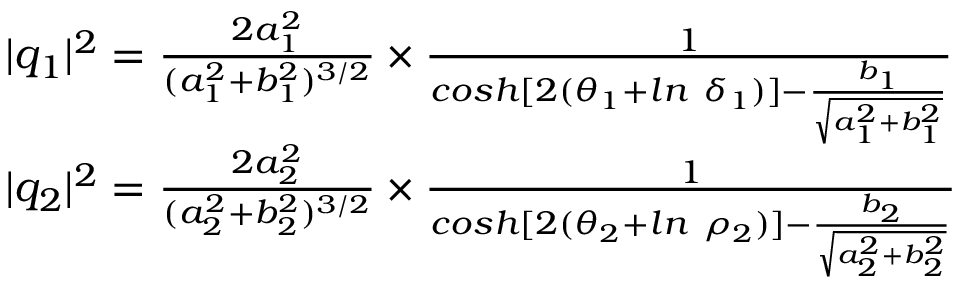Convert formula to latex. <formula><loc_0><loc_0><loc_500><loc_500>\begin{array} { r l } & { | q _ { 1 } | ^ { 2 } = \frac { 2 a _ { 1 } ^ { 2 } } { ( a _ { 1 } ^ { 2 } + b _ { 1 } ^ { 2 } ) ^ { 3 / 2 } } \times \frac { 1 } { \cosh [ 2 ( \theta _ { 1 } + \ln \ \delta _ { 1 } ) ] - \frac { b _ { 1 } } { \sqrt { a _ { 1 } ^ { 2 } + b _ { 1 } ^ { 2 } } } } } \\ & { | q _ { 2 } | ^ { 2 } = \frac { 2 a _ { 2 } ^ { 2 } } { ( a _ { 2 } ^ { 2 } + b _ { 2 } ^ { 2 } ) ^ { 3 / 2 } } \times \frac { 1 } { \cosh [ 2 ( \theta _ { 2 } + \ln \ \rho _ { 2 } ) ] - \frac { b _ { 2 } } { \sqrt { a _ { 2 } ^ { 2 } + b _ { 2 } ^ { 2 } } } } } \end{array}</formula> 